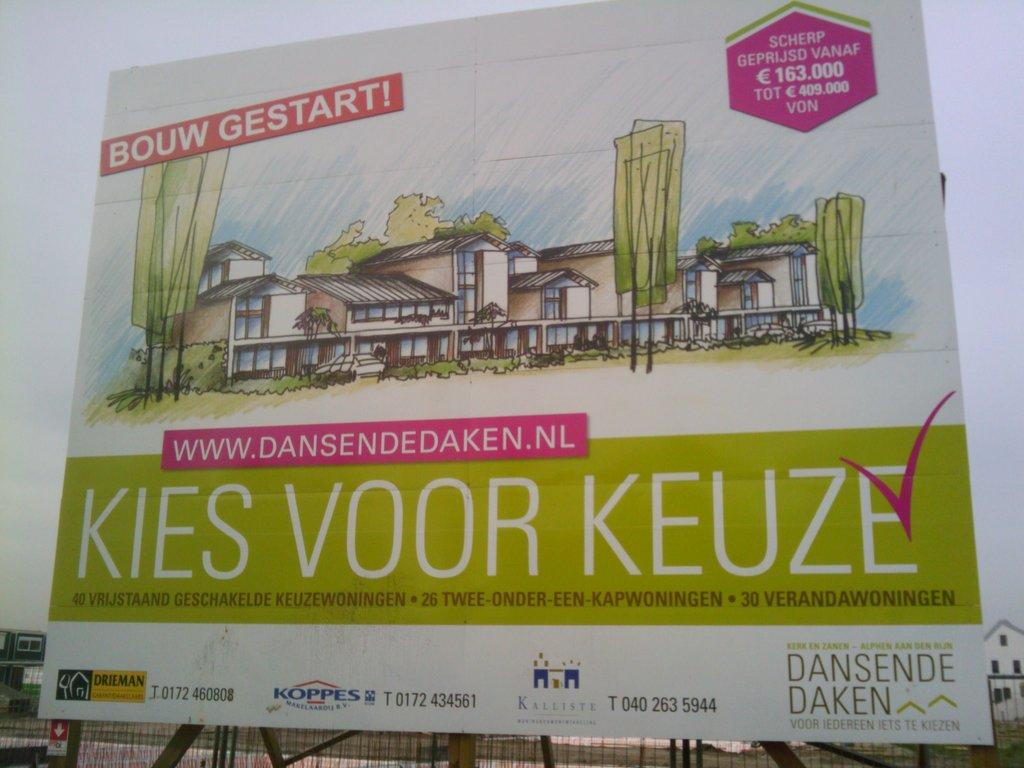<image>
Present a compact description of the photo's key features. an showing kies voor keuze is shown on a street 